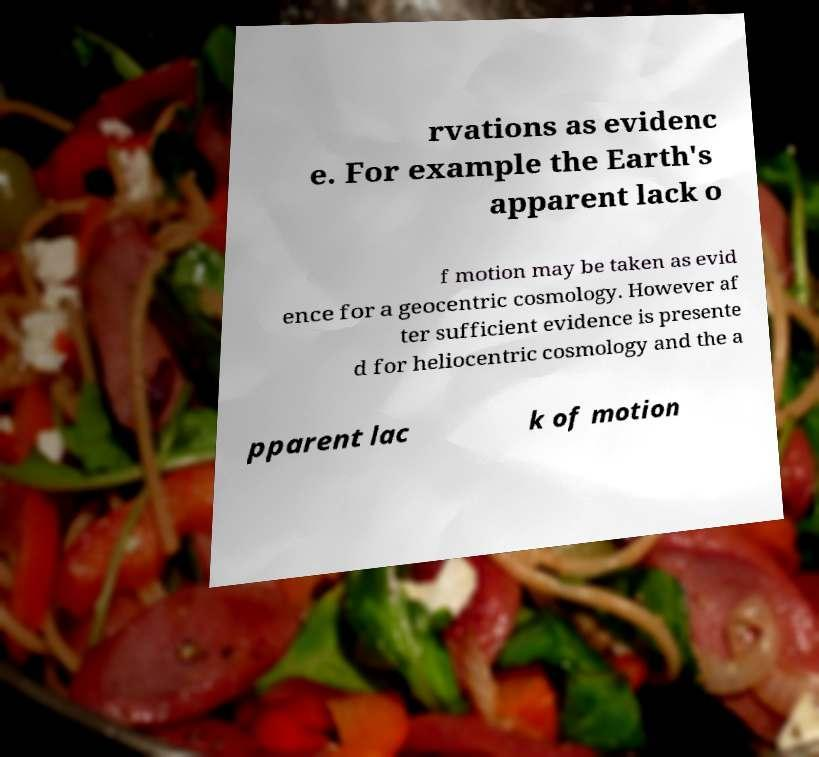What messages or text are displayed in this image? I need them in a readable, typed format. rvations as evidenc e. For example the Earth's apparent lack o f motion may be taken as evid ence for a geocentric cosmology. However af ter sufficient evidence is presente d for heliocentric cosmology and the a pparent lac k of motion 